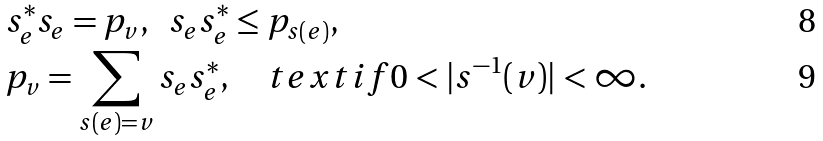<formula> <loc_0><loc_0><loc_500><loc_500>& s _ { e } ^ { * } s _ { e } = p _ { v } , \ \ s _ { e } s _ { e } ^ { * } \leq p _ { s ( e ) } , \\ & p _ { v } = \sum _ { s ( e ) = v } s _ { e } s _ { e } ^ { * } , \quad t e x t { i f } 0 < | s ^ { - 1 } ( v ) | < \infty .</formula> 